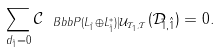Convert formula to latex. <formula><loc_0><loc_0><loc_500><loc_500>\sum _ { d _ { \tilde { 1 } } = 0 } { \mathcal { C } } _ { \ B b b { P } ( L _ { \tilde { 1 } } \oplus L _ { \tilde { 1 } } ^ { * } ) | { \mathcal { U } } _ { { \mathcal { T } } _ { 1 } , { \mathcal { T } } } } ( { \mathcal { D } } _ { \tilde { 1 } , \hat { 1 } } ) = 0 .</formula> 